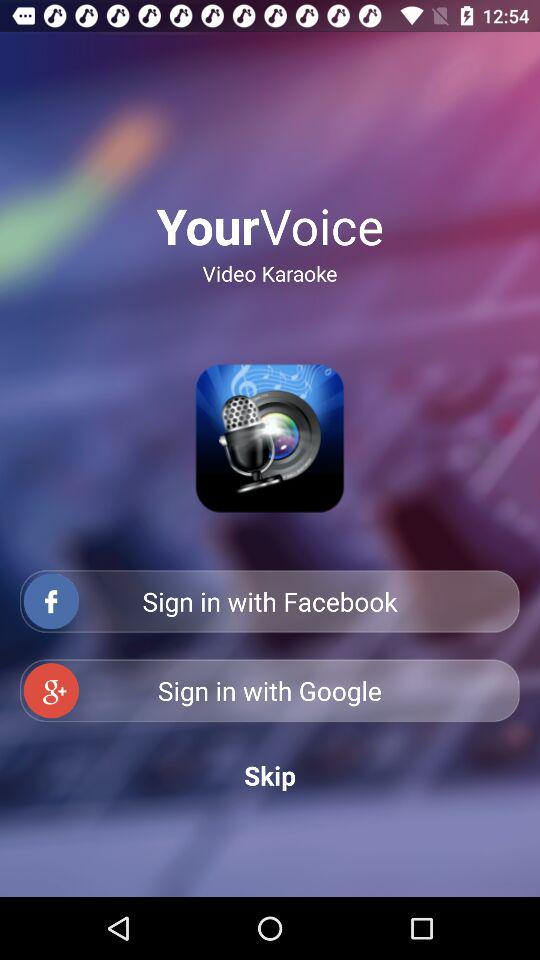What is the name of the application? The name of the application is "YourVoice". 